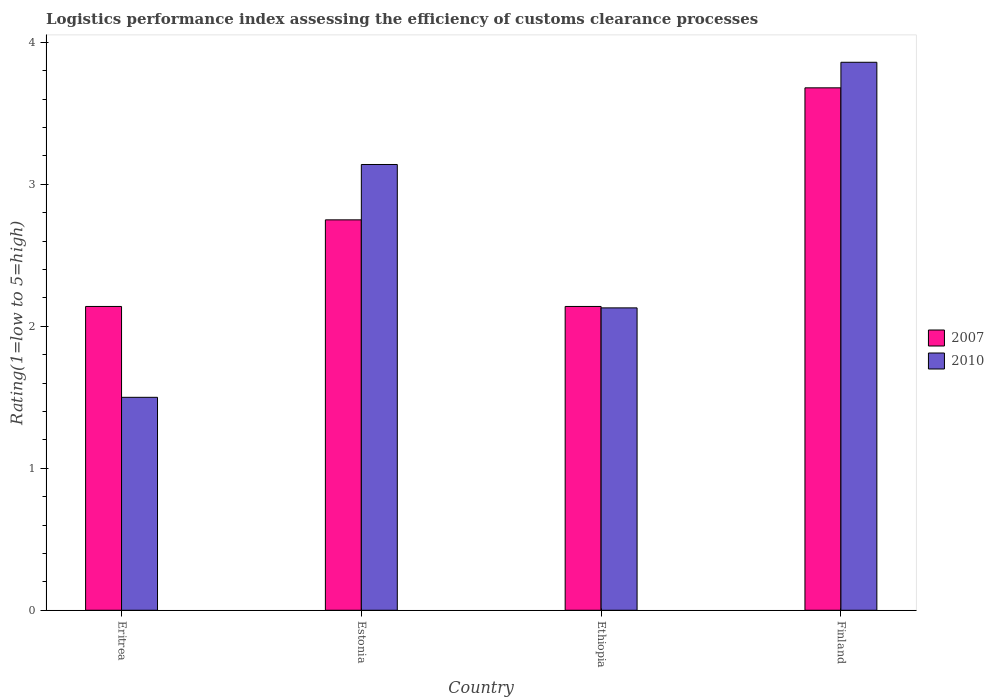How many different coloured bars are there?
Make the answer very short. 2. How many groups of bars are there?
Ensure brevity in your answer.  4. How many bars are there on the 1st tick from the left?
Keep it short and to the point. 2. What is the label of the 1st group of bars from the left?
Offer a very short reply. Eritrea. In how many cases, is the number of bars for a given country not equal to the number of legend labels?
Your answer should be compact. 0. What is the Logistic performance index in 2010 in Eritrea?
Give a very brief answer. 1.5. Across all countries, what is the maximum Logistic performance index in 2007?
Your response must be concise. 3.68. In which country was the Logistic performance index in 2010 maximum?
Your response must be concise. Finland. In which country was the Logistic performance index in 2007 minimum?
Offer a terse response. Eritrea. What is the total Logistic performance index in 2010 in the graph?
Give a very brief answer. 10.63. What is the difference between the Logistic performance index in 2010 in Eritrea and that in Estonia?
Give a very brief answer. -1.64. What is the difference between the Logistic performance index in 2007 in Finland and the Logistic performance index in 2010 in Ethiopia?
Provide a short and direct response. 1.55. What is the average Logistic performance index in 2010 per country?
Provide a short and direct response. 2.66. What is the difference between the Logistic performance index of/in 2007 and Logistic performance index of/in 2010 in Finland?
Provide a succinct answer. -0.18. In how many countries, is the Logistic performance index in 2007 greater than 1?
Give a very brief answer. 4. What is the ratio of the Logistic performance index in 2007 in Eritrea to that in Ethiopia?
Your answer should be very brief. 1. Is the Logistic performance index in 2007 in Estonia less than that in Finland?
Provide a short and direct response. Yes. What is the difference between the highest and the second highest Logistic performance index in 2007?
Provide a succinct answer. -0.93. What is the difference between the highest and the lowest Logistic performance index in 2010?
Make the answer very short. 2.36. In how many countries, is the Logistic performance index in 2007 greater than the average Logistic performance index in 2007 taken over all countries?
Keep it short and to the point. 2. Is the sum of the Logistic performance index in 2007 in Estonia and Ethiopia greater than the maximum Logistic performance index in 2010 across all countries?
Ensure brevity in your answer.  Yes. What does the 1st bar from the left in Eritrea represents?
Your answer should be very brief. 2007. What does the 2nd bar from the right in Finland represents?
Offer a terse response. 2007. How many countries are there in the graph?
Your answer should be compact. 4. What is the difference between two consecutive major ticks on the Y-axis?
Your answer should be very brief. 1. Does the graph contain any zero values?
Your answer should be very brief. No. Where does the legend appear in the graph?
Give a very brief answer. Center right. What is the title of the graph?
Keep it short and to the point. Logistics performance index assessing the efficiency of customs clearance processes. Does "1974" appear as one of the legend labels in the graph?
Provide a succinct answer. No. What is the label or title of the Y-axis?
Offer a terse response. Rating(1=low to 5=high). What is the Rating(1=low to 5=high) in 2007 in Eritrea?
Provide a short and direct response. 2.14. What is the Rating(1=low to 5=high) in 2007 in Estonia?
Your response must be concise. 2.75. What is the Rating(1=low to 5=high) of 2010 in Estonia?
Make the answer very short. 3.14. What is the Rating(1=low to 5=high) of 2007 in Ethiopia?
Provide a short and direct response. 2.14. What is the Rating(1=low to 5=high) in 2010 in Ethiopia?
Make the answer very short. 2.13. What is the Rating(1=low to 5=high) of 2007 in Finland?
Give a very brief answer. 3.68. What is the Rating(1=low to 5=high) in 2010 in Finland?
Offer a very short reply. 3.86. Across all countries, what is the maximum Rating(1=low to 5=high) of 2007?
Your response must be concise. 3.68. Across all countries, what is the maximum Rating(1=low to 5=high) of 2010?
Provide a short and direct response. 3.86. Across all countries, what is the minimum Rating(1=low to 5=high) of 2007?
Your answer should be very brief. 2.14. What is the total Rating(1=low to 5=high) of 2007 in the graph?
Your response must be concise. 10.71. What is the total Rating(1=low to 5=high) in 2010 in the graph?
Ensure brevity in your answer.  10.63. What is the difference between the Rating(1=low to 5=high) in 2007 in Eritrea and that in Estonia?
Offer a very short reply. -0.61. What is the difference between the Rating(1=low to 5=high) in 2010 in Eritrea and that in Estonia?
Give a very brief answer. -1.64. What is the difference between the Rating(1=low to 5=high) in 2010 in Eritrea and that in Ethiopia?
Your answer should be very brief. -0.63. What is the difference between the Rating(1=low to 5=high) of 2007 in Eritrea and that in Finland?
Provide a short and direct response. -1.54. What is the difference between the Rating(1=low to 5=high) of 2010 in Eritrea and that in Finland?
Offer a terse response. -2.36. What is the difference between the Rating(1=low to 5=high) in 2007 in Estonia and that in Ethiopia?
Your answer should be very brief. 0.61. What is the difference between the Rating(1=low to 5=high) in 2007 in Estonia and that in Finland?
Provide a succinct answer. -0.93. What is the difference between the Rating(1=low to 5=high) in 2010 in Estonia and that in Finland?
Offer a very short reply. -0.72. What is the difference between the Rating(1=low to 5=high) of 2007 in Ethiopia and that in Finland?
Offer a very short reply. -1.54. What is the difference between the Rating(1=low to 5=high) of 2010 in Ethiopia and that in Finland?
Your response must be concise. -1.73. What is the difference between the Rating(1=low to 5=high) in 2007 in Eritrea and the Rating(1=low to 5=high) in 2010 in Finland?
Offer a terse response. -1.72. What is the difference between the Rating(1=low to 5=high) of 2007 in Estonia and the Rating(1=low to 5=high) of 2010 in Ethiopia?
Provide a succinct answer. 0.62. What is the difference between the Rating(1=low to 5=high) in 2007 in Estonia and the Rating(1=low to 5=high) in 2010 in Finland?
Provide a succinct answer. -1.11. What is the difference between the Rating(1=low to 5=high) of 2007 in Ethiopia and the Rating(1=low to 5=high) of 2010 in Finland?
Your answer should be compact. -1.72. What is the average Rating(1=low to 5=high) in 2007 per country?
Ensure brevity in your answer.  2.68. What is the average Rating(1=low to 5=high) of 2010 per country?
Ensure brevity in your answer.  2.66. What is the difference between the Rating(1=low to 5=high) of 2007 and Rating(1=low to 5=high) of 2010 in Eritrea?
Your answer should be compact. 0.64. What is the difference between the Rating(1=low to 5=high) in 2007 and Rating(1=low to 5=high) in 2010 in Estonia?
Your answer should be very brief. -0.39. What is the difference between the Rating(1=low to 5=high) in 2007 and Rating(1=low to 5=high) in 2010 in Ethiopia?
Your answer should be compact. 0.01. What is the difference between the Rating(1=low to 5=high) of 2007 and Rating(1=low to 5=high) of 2010 in Finland?
Your answer should be very brief. -0.18. What is the ratio of the Rating(1=low to 5=high) in 2007 in Eritrea to that in Estonia?
Your answer should be very brief. 0.78. What is the ratio of the Rating(1=low to 5=high) of 2010 in Eritrea to that in Estonia?
Make the answer very short. 0.48. What is the ratio of the Rating(1=low to 5=high) in 2010 in Eritrea to that in Ethiopia?
Make the answer very short. 0.7. What is the ratio of the Rating(1=low to 5=high) of 2007 in Eritrea to that in Finland?
Your answer should be very brief. 0.58. What is the ratio of the Rating(1=low to 5=high) of 2010 in Eritrea to that in Finland?
Keep it short and to the point. 0.39. What is the ratio of the Rating(1=low to 5=high) in 2007 in Estonia to that in Ethiopia?
Keep it short and to the point. 1.28. What is the ratio of the Rating(1=low to 5=high) in 2010 in Estonia to that in Ethiopia?
Your answer should be very brief. 1.47. What is the ratio of the Rating(1=low to 5=high) in 2007 in Estonia to that in Finland?
Provide a succinct answer. 0.75. What is the ratio of the Rating(1=low to 5=high) in 2010 in Estonia to that in Finland?
Offer a terse response. 0.81. What is the ratio of the Rating(1=low to 5=high) of 2007 in Ethiopia to that in Finland?
Your answer should be compact. 0.58. What is the ratio of the Rating(1=low to 5=high) of 2010 in Ethiopia to that in Finland?
Your answer should be compact. 0.55. What is the difference between the highest and the second highest Rating(1=low to 5=high) of 2007?
Provide a short and direct response. 0.93. What is the difference between the highest and the second highest Rating(1=low to 5=high) of 2010?
Your answer should be very brief. 0.72. What is the difference between the highest and the lowest Rating(1=low to 5=high) in 2007?
Keep it short and to the point. 1.54. What is the difference between the highest and the lowest Rating(1=low to 5=high) of 2010?
Offer a terse response. 2.36. 